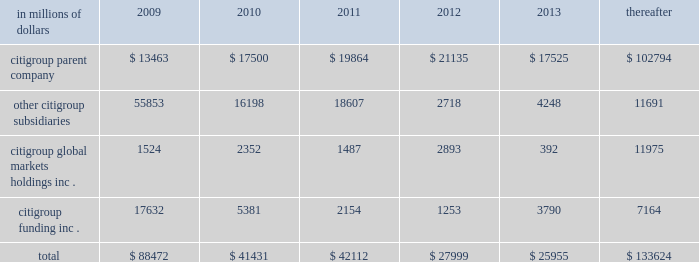Cgmhi also has substantial borrowing arrangements consisting of facilities that cgmhi has been advised are available , but where no contractual lending obligation exists .
These arrangements are reviewed on an ongoing basis to ensure flexibility in meeting cgmhi 2019s short-term requirements .
The company issues both fixed and variable rate debt in a range of currencies .
It uses derivative contracts , primarily interest rate swaps , to effectively convert a portion of its fixed rate debt to variable rate debt and variable rate debt to fixed rate debt .
The maturity structure of the derivatives generally corresponds to the maturity structure of the debt being hedged .
In addition , the company uses other derivative contracts to manage the foreign exchange impact of certain debt issuances .
At december 31 , 2008 , the company 2019s overall weighted average interest rate for long-term debt was 3.83% ( 3.83 % ) on a contractual basis and 4.19% ( 4.19 % ) including the effects of derivative contracts .
Aggregate annual maturities of long-term debt obligations ( based on final maturity dates ) including trust preferred securities are as follows : in millions of dollars 2009 2010 2011 2012 2013 thereafter .
Long-term debt at december 31 , 2008 and december 31 , 2007 includes $ 24060 million and $ 23756 million , respectively , of junior subordinated debt .
The company formed statutory business trusts under the laws of the state of delaware .
The trusts exist for the exclusive purposes of ( i ) issuing trust securities representing undivided beneficial interests in the assets of the trust ; ( ii ) investing the gross proceeds of the trust securities in junior subordinated deferrable interest debentures ( subordinated debentures ) of its parent ; and ( iii ) engaging in only those activities necessary or incidental thereto .
Upon approval from the federal reserve , citigroup has the right to redeem these securities .
Citigroup has contractually agreed not to redeem or purchase ( i ) the 6.50% ( 6.50 % ) enhanced trust preferred securities of citigroup capital xv before september 15 , 2056 , ( ii ) the 6.45% ( 6.45 % ) enhanced trust preferred securities of citigroup capital xvi before december 31 , 2046 , ( iii ) the 6.35% ( 6.35 % ) enhanced trust preferred securities of citigroup capital xvii before march 15 , 2057 , ( iv ) the 6.829% ( 6.829 % ) fixed rate/floating rate enhanced trust preferred securities of citigroup capital xviii before june 28 , 2047 , ( v ) the 7.250% ( 7.250 % ) enhanced trust preferred securities of citigroup capital xix before august 15 , 2047 , ( vi ) the 7.875% ( 7.875 % ) enhanced trust preferred securities of citigroup capital xx before december 15 , 2067 , and ( vii ) the 8.300% ( 8.300 % ) fixed rate/floating rate enhanced trust preferred securities of citigroup capital xxi before december 21 , 2067 unless certain conditions , described in exhibit 4.03 to citigroup 2019s current report on form 8-k filed on september 18 , 2006 , in exhibit 4.02 to citigroup 2019s current report on form 8-k filed on november 28 , 2006 , in exhibit 4.02 to citigroup 2019s current report on form 8-k filed on march 8 , 2007 , in exhibit 4.02 to citigroup 2019s current report on form 8-k filed on july 2 , 2007 , in exhibit 4.02 to citigroup 2019s current report on form 8-k filed on august 17 , 2007 , in exhibit 4.2 to citigroup 2019s current report on form 8-k filed on november 27 , 2007 , and in exhibit 4.2 to citigroup 2019s current report on form 8-k filed on december 21 , 2007 , respectively , are met .
These agreements are for the benefit of the holders of citigroup 2019s 6.00% ( 6.00 % ) junior subordinated deferrable interest debentures due 2034 .
Citigroup owns all of the voting securities of these subsidiary trusts .
These subsidiary trusts have no assets , operations , revenues or cash flows other than those related to the issuance , administration and repayment of the subsidiary trusts and the subsidiary trusts 2019 common securities .
These subsidiary trusts 2019 obligations are fully and unconditionally guaranteed by citigroup. .
What was the ratio of the junior subordinated debt . long-term debt of 2007 to 2008? 
Computations: (23756 / 24060)
Answer: 0.98736. 